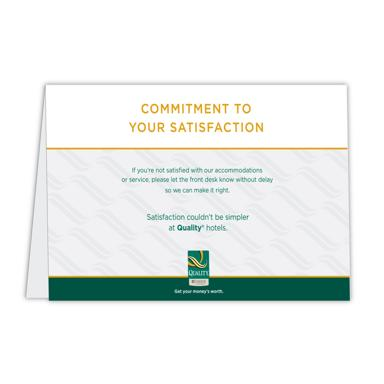What font style is used in 'COMMITMENT TO YOUR SATISFACTION' on the card? The phrase 'COMMITMENT TO YOUR SATISFACTION' is written in a bold, sans-serif font, which conveys clarity and emphasis. The choice of a sans-serif font enhances the card's contemporary aesthetic while ensuring that the message is direct and easily digestible. How does this choice of font contribute to the card's overall impact? The bold, sans-serif font contributes to a strong, forthright presentation of the hotel's guarantee of satisfaction. It makes the commitment statement immediately noticeable, aiding in conveying a sense of assurance and professionalism. This font style complements the card's design aim to communicate reliability and approachability. 